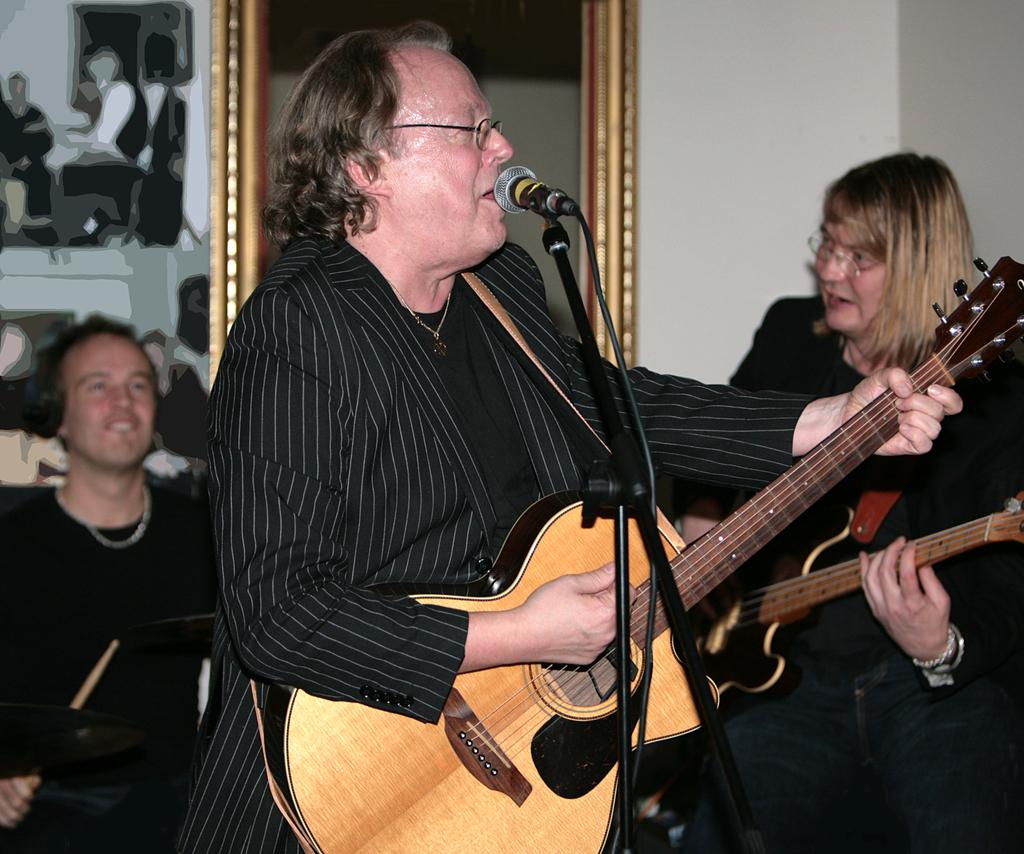What is the main activity of the people in the image? The people in the image are playing musical instruments and singing. How many people are playing guitar in the image? There are two men playing guitar in the image. What other musical instrument can be seen in the image? There is a man playing drums in the background. What type of cloth is being used to cover the guitar in the image? There is no cloth covering any of the guitars in the image. Is there a clock visible in the image? There is no clock present in the image. 